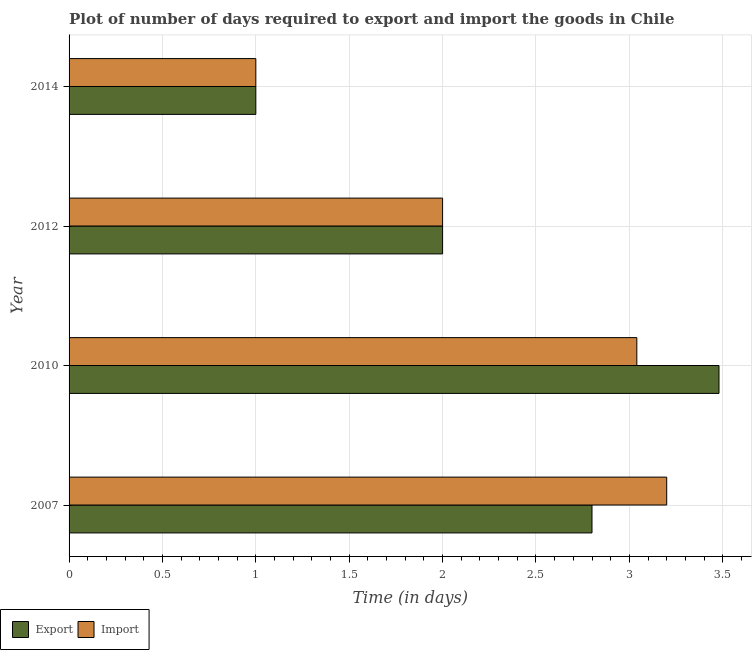How many different coloured bars are there?
Provide a short and direct response. 2. Are the number of bars per tick equal to the number of legend labels?
Keep it short and to the point. Yes. How many bars are there on the 3rd tick from the top?
Your answer should be very brief. 2. How many bars are there on the 3rd tick from the bottom?
Ensure brevity in your answer.  2. What is the time required to export in 2010?
Provide a short and direct response. 3.48. In which year was the time required to import minimum?
Provide a succinct answer. 2014. What is the total time required to export in the graph?
Provide a succinct answer. 9.28. What is the difference between the time required to import in 2010 and that in 2012?
Your answer should be compact. 1.04. What is the difference between the time required to import in 2010 and the time required to export in 2014?
Offer a very short reply. 2.04. What is the average time required to import per year?
Your response must be concise. 2.31. In the year 2010, what is the difference between the time required to export and time required to import?
Offer a terse response. 0.44. In how many years, is the time required to export greater than 1.5 days?
Your response must be concise. 3. Is the time required to export in 2007 less than that in 2014?
Offer a terse response. No. What is the difference between the highest and the second highest time required to import?
Ensure brevity in your answer.  0.16. What is the difference between the highest and the lowest time required to export?
Your answer should be very brief. 2.48. What does the 2nd bar from the top in 2007 represents?
Keep it short and to the point. Export. What does the 2nd bar from the bottom in 2012 represents?
Give a very brief answer. Import. Are all the bars in the graph horizontal?
Your response must be concise. Yes. Are the values on the major ticks of X-axis written in scientific E-notation?
Offer a very short reply. No. Does the graph contain any zero values?
Your answer should be compact. No. Does the graph contain grids?
Ensure brevity in your answer.  Yes. How many legend labels are there?
Ensure brevity in your answer.  2. What is the title of the graph?
Offer a very short reply. Plot of number of days required to export and import the goods in Chile. What is the label or title of the X-axis?
Keep it short and to the point. Time (in days). What is the label or title of the Y-axis?
Keep it short and to the point. Year. What is the Time (in days) in Export in 2007?
Keep it short and to the point. 2.8. What is the Time (in days) in Export in 2010?
Offer a terse response. 3.48. What is the Time (in days) of Import in 2010?
Your response must be concise. 3.04. What is the Time (in days) in Import in 2012?
Provide a short and direct response. 2. What is the Time (in days) in Export in 2014?
Provide a short and direct response. 1. Across all years, what is the maximum Time (in days) of Export?
Offer a very short reply. 3.48. Across all years, what is the minimum Time (in days) in Export?
Ensure brevity in your answer.  1. What is the total Time (in days) of Export in the graph?
Give a very brief answer. 9.28. What is the total Time (in days) in Import in the graph?
Offer a very short reply. 9.24. What is the difference between the Time (in days) in Export in 2007 and that in 2010?
Give a very brief answer. -0.68. What is the difference between the Time (in days) of Import in 2007 and that in 2010?
Provide a short and direct response. 0.16. What is the difference between the Time (in days) in Export in 2007 and that in 2012?
Offer a very short reply. 0.8. What is the difference between the Time (in days) of Import in 2007 and that in 2012?
Your answer should be very brief. 1.2. What is the difference between the Time (in days) of Export in 2007 and that in 2014?
Offer a terse response. 1.8. What is the difference between the Time (in days) of Export in 2010 and that in 2012?
Your answer should be very brief. 1.48. What is the difference between the Time (in days) in Export in 2010 and that in 2014?
Offer a very short reply. 2.48. What is the difference between the Time (in days) of Import in 2010 and that in 2014?
Give a very brief answer. 2.04. What is the difference between the Time (in days) of Export in 2012 and that in 2014?
Keep it short and to the point. 1. What is the difference between the Time (in days) of Import in 2012 and that in 2014?
Your answer should be very brief. 1. What is the difference between the Time (in days) of Export in 2007 and the Time (in days) of Import in 2010?
Make the answer very short. -0.24. What is the difference between the Time (in days) in Export in 2007 and the Time (in days) in Import in 2014?
Offer a very short reply. 1.8. What is the difference between the Time (in days) of Export in 2010 and the Time (in days) of Import in 2012?
Ensure brevity in your answer.  1.48. What is the difference between the Time (in days) in Export in 2010 and the Time (in days) in Import in 2014?
Give a very brief answer. 2.48. What is the difference between the Time (in days) in Export in 2012 and the Time (in days) in Import in 2014?
Your answer should be compact. 1. What is the average Time (in days) in Export per year?
Keep it short and to the point. 2.32. What is the average Time (in days) in Import per year?
Make the answer very short. 2.31. In the year 2010, what is the difference between the Time (in days) in Export and Time (in days) in Import?
Your answer should be compact. 0.44. In the year 2014, what is the difference between the Time (in days) in Export and Time (in days) in Import?
Your response must be concise. 0. What is the ratio of the Time (in days) in Export in 2007 to that in 2010?
Provide a short and direct response. 0.8. What is the ratio of the Time (in days) in Import in 2007 to that in 2010?
Your answer should be very brief. 1.05. What is the ratio of the Time (in days) in Import in 2007 to that in 2012?
Your answer should be compact. 1.6. What is the ratio of the Time (in days) of Export in 2010 to that in 2012?
Your answer should be very brief. 1.74. What is the ratio of the Time (in days) in Import in 2010 to that in 2012?
Offer a terse response. 1.52. What is the ratio of the Time (in days) in Export in 2010 to that in 2014?
Ensure brevity in your answer.  3.48. What is the ratio of the Time (in days) of Import in 2010 to that in 2014?
Provide a short and direct response. 3.04. What is the ratio of the Time (in days) in Export in 2012 to that in 2014?
Your answer should be compact. 2. What is the ratio of the Time (in days) of Import in 2012 to that in 2014?
Your answer should be compact. 2. What is the difference between the highest and the second highest Time (in days) in Export?
Keep it short and to the point. 0.68. What is the difference between the highest and the second highest Time (in days) in Import?
Provide a succinct answer. 0.16. What is the difference between the highest and the lowest Time (in days) in Export?
Provide a short and direct response. 2.48. What is the difference between the highest and the lowest Time (in days) of Import?
Provide a succinct answer. 2.2. 